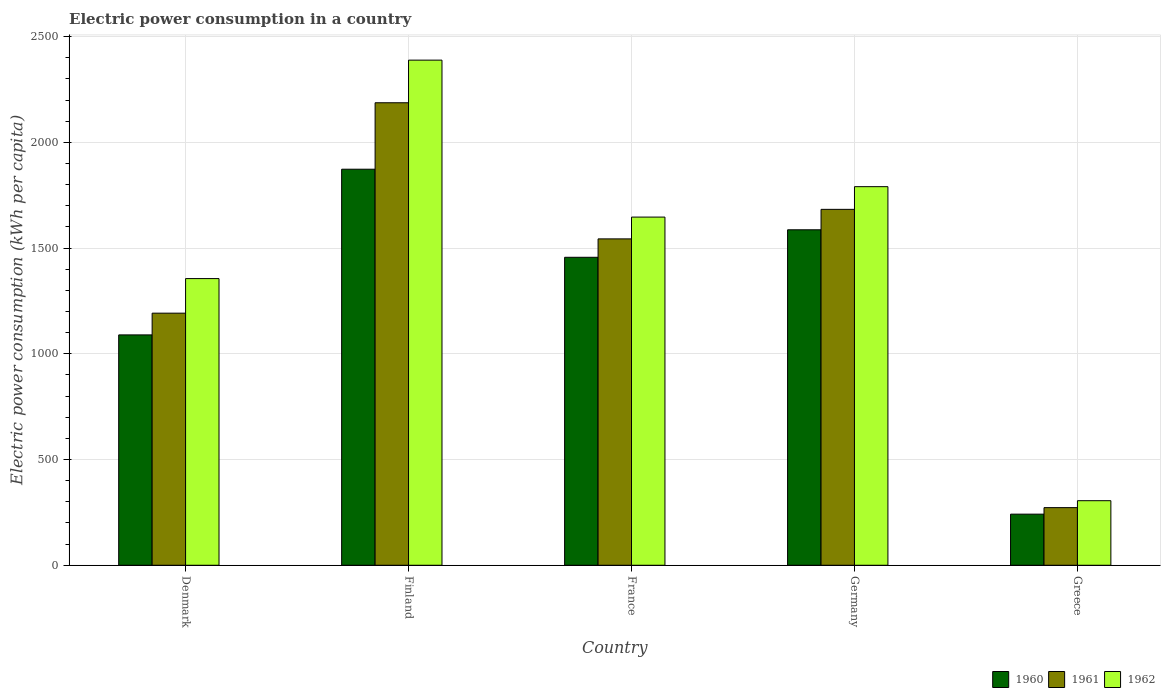How many different coloured bars are there?
Keep it short and to the point. 3. Are the number of bars on each tick of the X-axis equal?
Offer a very short reply. Yes. How many bars are there on the 2nd tick from the right?
Offer a very short reply. 3. What is the label of the 2nd group of bars from the left?
Make the answer very short. Finland. In how many cases, is the number of bars for a given country not equal to the number of legend labels?
Offer a very short reply. 0. What is the electric power consumption in in 1961 in France?
Your response must be concise. 1543.71. Across all countries, what is the maximum electric power consumption in in 1960?
Give a very brief answer. 1873.29. Across all countries, what is the minimum electric power consumption in in 1962?
Offer a terse response. 305.39. In which country was the electric power consumption in in 1961 maximum?
Keep it short and to the point. Finland. What is the total electric power consumption in in 1960 in the graph?
Ensure brevity in your answer.  6248.08. What is the difference between the electric power consumption in in 1962 in France and that in Germany?
Keep it short and to the point. -143.85. What is the difference between the electric power consumption in in 1960 in Greece and the electric power consumption in in 1962 in France?
Provide a short and direct response. -1405.11. What is the average electric power consumption in in 1961 per country?
Your answer should be compact. 1375.94. What is the difference between the electric power consumption in of/in 1962 and electric power consumption in of/in 1961 in Finland?
Your response must be concise. 201.59. What is the ratio of the electric power consumption in in 1961 in Denmark to that in France?
Your answer should be very brief. 0.77. Is the difference between the electric power consumption in in 1962 in Germany and Greece greater than the difference between the electric power consumption in in 1961 in Germany and Greece?
Keep it short and to the point. Yes. What is the difference between the highest and the second highest electric power consumption in in 1960?
Provide a short and direct response. -416.6. What is the difference between the highest and the lowest electric power consumption in in 1961?
Offer a terse response. 1915.06. What is the difference between two consecutive major ticks on the Y-axis?
Your answer should be compact. 500. Are the values on the major ticks of Y-axis written in scientific E-notation?
Your response must be concise. No. Does the graph contain any zero values?
Provide a short and direct response. No. Where does the legend appear in the graph?
Your response must be concise. Bottom right. How many legend labels are there?
Give a very brief answer. 3. What is the title of the graph?
Provide a succinct answer. Electric power consumption in a country. What is the label or title of the Y-axis?
Provide a short and direct response. Electric power consumption (kWh per capita). What is the Electric power consumption (kWh per capita) in 1960 in Denmark?
Offer a very short reply. 1089.61. What is the Electric power consumption (kWh per capita) in 1961 in Denmark?
Your response must be concise. 1192.41. What is the Electric power consumption (kWh per capita) in 1962 in Denmark?
Offer a terse response. 1355.93. What is the Electric power consumption (kWh per capita) in 1960 in Finland?
Offer a terse response. 1873.29. What is the Electric power consumption (kWh per capita) in 1961 in Finland?
Your answer should be compact. 2187.62. What is the Electric power consumption (kWh per capita) in 1962 in Finland?
Your answer should be very brief. 2389.21. What is the Electric power consumption (kWh per capita) of 1960 in France?
Offer a terse response. 1456.69. What is the Electric power consumption (kWh per capita) in 1961 in France?
Make the answer very short. 1543.71. What is the Electric power consumption (kWh per capita) of 1962 in France?
Provide a short and direct response. 1646.83. What is the Electric power consumption (kWh per capita) of 1960 in Germany?
Make the answer very short. 1586.75. What is the Electric power consumption (kWh per capita) of 1961 in Germany?
Make the answer very short. 1683.41. What is the Electric power consumption (kWh per capita) of 1962 in Germany?
Your answer should be compact. 1790.69. What is the Electric power consumption (kWh per capita) in 1960 in Greece?
Make the answer very short. 241.73. What is the Electric power consumption (kWh per capita) in 1961 in Greece?
Make the answer very short. 272.56. What is the Electric power consumption (kWh per capita) of 1962 in Greece?
Your response must be concise. 305.39. Across all countries, what is the maximum Electric power consumption (kWh per capita) in 1960?
Ensure brevity in your answer.  1873.29. Across all countries, what is the maximum Electric power consumption (kWh per capita) of 1961?
Keep it short and to the point. 2187.62. Across all countries, what is the maximum Electric power consumption (kWh per capita) in 1962?
Keep it short and to the point. 2389.21. Across all countries, what is the minimum Electric power consumption (kWh per capita) in 1960?
Offer a very short reply. 241.73. Across all countries, what is the minimum Electric power consumption (kWh per capita) in 1961?
Give a very brief answer. 272.56. Across all countries, what is the minimum Electric power consumption (kWh per capita) of 1962?
Make the answer very short. 305.39. What is the total Electric power consumption (kWh per capita) of 1960 in the graph?
Your response must be concise. 6248.08. What is the total Electric power consumption (kWh per capita) of 1961 in the graph?
Your answer should be very brief. 6879.72. What is the total Electric power consumption (kWh per capita) of 1962 in the graph?
Make the answer very short. 7488.05. What is the difference between the Electric power consumption (kWh per capita) in 1960 in Denmark and that in Finland?
Give a very brief answer. -783.68. What is the difference between the Electric power consumption (kWh per capita) in 1961 in Denmark and that in Finland?
Your answer should be very brief. -995.22. What is the difference between the Electric power consumption (kWh per capita) in 1962 in Denmark and that in Finland?
Offer a terse response. -1033.28. What is the difference between the Electric power consumption (kWh per capita) of 1960 in Denmark and that in France?
Provide a succinct answer. -367.08. What is the difference between the Electric power consumption (kWh per capita) in 1961 in Denmark and that in France?
Provide a succinct answer. -351.31. What is the difference between the Electric power consumption (kWh per capita) in 1962 in Denmark and that in France?
Provide a succinct answer. -290.9. What is the difference between the Electric power consumption (kWh per capita) in 1960 in Denmark and that in Germany?
Offer a terse response. -497.14. What is the difference between the Electric power consumption (kWh per capita) in 1961 in Denmark and that in Germany?
Keep it short and to the point. -491.01. What is the difference between the Electric power consumption (kWh per capita) in 1962 in Denmark and that in Germany?
Your answer should be compact. -434.76. What is the difference between the Electric power consumption (kWh per capita) of 1960 in Denmark and that in Greece?
Provide a succinct answer. 847.89. What is the difference between the Electric power consumption (kWh per capita) in 1961 in Denmark and that in Greece?
Your answer should be very brief. 919.84. What is the difference between the Electric power consumption (kWh per capita) of 1962 in Denmark and that in Greece?
Give a very brief answer. 1050.54. What is the difference between the Electric power consumption (kWh per capita) of 1960 in Finland and that in France?
Provide a succinct answer. 416.6. What is the difference between the Electric power consumption (kWh per capita) in 1961 in Finland and that in France?
Make the answer very short. 643.91. What is the difference between the Electric power consumption (kWh per capita) in 1962 in Finland and that in France?
Provide a succinct answer. 742.38. What is the difference between the Electric power consumption (kWh per capita) of 1960 in Finland and that in Germany?
Your response must be concise. 286.54. What is the difference between the Electric power consumption (kWh per capita) in 1961 in Finland and that in Germany?
Your answer should be very brief. 504.21. What is the difference between the Electric power consumption (kWh per capita) of 1962 in Finland and that in Germany?
Your answer should be compact. 598.52. What is the difference between the Electric power consumption (kWh per capita) in 1960 in Finland and that in Greece?
Your response must be concise. 1631.57. What is the difference between the Electric power consumption (kWh per capita) of 1961 in Finland and that in Greece?
Provide a short and direct response. 1915.06. What is the difference between the Electric power consumption (kWh per capita) in 1962 in Finland and that in Greece?
Your answer should be compact. 2083.82. What is the difference between the Electric power consumption (kWh per capita) of 1960 in France and that in Germany?
Make the answer very short. -130.06. What is the difference between the Electric power consumption (kWh per capita) of 1961 in France and that in Germany?
Offer a terse response. -139.7. What is the difference between the Electric power consumption (kWh per capita) in 1962 in France and that in Germany?
Your answer should be compact. -143.85. What is the difference between the Electric power consumption (kWh per capita) in 1960 in France and that in Greece?
Keep it short and to the point. 1214.97. What is the difference between the Electric power consumption (kWh per capita) of 1961 in France and that in Greece?
Provide a short and direct response. 1271.15. What is the difference between the Electric power consumption (kWh per capita) in 1962 in France and that in Greece?
Keep it short and to the point. 1341.44. What is the difference between the Electric power consumption (kWh per capita) of 1960 in Germany and that in Greece?
Your answer should be compact. 1345.02. What is the difference between the Electric power consumption (kWh per capita) in 1961 in Germany and that in Greece?
Give a very brief answer. 1410.85. What is the difference between the Electric power consumption (kWh per capita) in 1962 in Germany and that in Greece?
Your response must be concise. 1485.3. What is the difference between the Electric power consumption (kWh per capita) in 1960 in Denmark and the Electric power consumption (kWh per capita) in 1961 in Finland?
Give a very brief answer. -1098.01. What is the difference between the Electric power consumption (kWh per capita) of 1960 in Denmark and the Electric power consumption (kWh per capita) of 1962 in Finland?
Offer a terse response. -1299.6. What is the difference between the Electric power consumption (kWh per capita) of 1961 in Denmark and the Electric power consumption (kWh per capita) of 1962 in Finland?
Keep it short and to the point. -1196.8. What is the difference between the Electric power consumption (kWh per capita) of 1960 in Denmark and the Electric power consumption (kWh per capita) of 1961 in France?
Provide a short and direct response. -454.1. What is the difference between the Electric power consumption (kWh per capita) in 1960 in Denmark and the Electric power consumption (kWh per capita) in 1962 in France?
Keep it short and to the point. -557.22. What is the difference between the Electric power consumption (kWh per capita) in 1961 in Denmark and the Electric power consumption (kWh per capita) in 1962 in France?
Keep it short and to the point. -454.43. What is the difference between the Electric power consumption (kWh per capita) of 1960 in Denmark and the Electric power consumption (kWh per capita) of 1961 in Germany?
Give a very brief answer. -593.8. What is the difference between the Electric power consumption (kWh per capita) in 1960 in Denmark and the Electric power consumption (kWh per capita) in 1962 in Germany?
Offer a very short reply. -701.07. What is the difference between the Electric power consumption (kWh per capita) in 1961 in Denmark and the Electric power consumption (kWh per capita) in 1962 in Germany?
Your answer should be very brief. -598.28. What is the difference between the Electric power consumption (kWh per capita) of 1960 in Denmark and the Electric power consumption (kWh per capita) of 1961 in Greece?
Keep it short and to the point. 817.05. What is the difference between the Electric power consumption (kWh per capita) in 1960 in Denmark and the Electric power consumption (kWh per capita) in 1962 in Greece?
Offer a very short reply. 784.22. What is the difference between the Electric power consumption (kWh per capita) of 1961 in Denmark and the Electric power consumption (kWh per capita) of 1962 in Greece?
Give a very brief answer. 887.02. What is the difference between the Electric power consumption (kWh per capita) of 1960 in Finland and the Electric power consumption (kWh per capita) of 1961 in France?
Provide a short and direct response. 329.58. What is the difference between the Electric power consumption (kWh per capita) of 1960 in Finland and the Electric power consumption (kWh per capita) of 1962 in France?
Provide a short and direct response. 226.46. What is the difference between the Electric power consumption (kWh per capita) in 1961 in Finland and the Electric power consumption (kWh per capita) in 1962 in France?
Provide a short and direct response. 540.79. What is the difference between the Electric power consumption (kWh per capita) of 1960 in Finland and the Electric power consumption (kWh per capita) of 1961 in Germany?
Offer a terse response. 189.88. What is the difference between the Electric power consumption (kWh per capita) in 1960 in Finland and the Electric power consumption (kWh per capita) in 1962 in Germany?
Keep it short and to the point. 82.61. What is the difference between the Electric power consumption (kWh per capita) of 1961 in Finland and the Electric power consumption (kWh per capita) of 1962 in Germany?
Provide a short and direct response. 396.94. What is the difference between the Electric power consumption (kWh per capita) in 1960 in Finland and the Electric power consumption (kWh per capita) in 1961 in Greece?
Make the answer very short. 1600.73. What is the difference between the Electric power consumption (kWh per capita) in 1960 in Finland and the Electric power consumption (kWh per capita) in 1962 in Greece?
Ensure brevity in your answer.  1567.9. What is the difference between the Electric power consumption (kWh per capita) in 1961 in Finland and the Electric power consumption (kWh per capita) in 1962 in Greece?
Keep it short and to the point. 1882.23. What is the difference between the Electric power consumption (kWh per capita) in 1960 in France and the Electric power consumption (kWh per capita) in 1961 in Germany?
Offer a very short reply. -226.72. What is the difference between the Electric power consumption (kWh per capita) in 1960 in France and the Electric power consumption (kWh per capita) in 1962 in Germany?
Offer a very short reply. -333.99. What is the difference between the Electric power consumption (kWh per capita) of 1961 in France and the Electric power consumption (kWh per capita) of 1962 in Germany?
Make the answer very short. -246.98. What is the difference between the Electric power consumption (kWh per capita) of 1960 in France and the Electric power consumption (kWh per capita) of 1961 in Greece?
Offer a very short reply. 1184.13. What is the difference between the Electric power consumption (kWh per capita) of 1960 in France and the Electric power consumption (kWh per capita) of 1962 in Greece?
Ensure brevity in your answer.  1151.3. What is the difference between the Electric power consumption (kWh per capita) of 1961 in France and the Electric power consumption (kWh per capita) of 1962 in Greece?
Keep it short and to the point. 1238.32. What is the difference between the Electric power consumption (kWh per capita) in 1960 in Germany and the Electric power consumption (kWh per capita) in 1961 in Greece?
Your answer should be very brief. 1314.19. What is the difference between the Electric power consumption (kWh per capita) of 1960 in Germany and the Electric power consumption (kWh per capita) of 1962 in Greece?
Offer a very short reply. 1281.36. What is the difference between the Electric power consumption (kWh per capita) in 1961 in Germany and the Electric power consumption (kWh per capita) in 1962 in Greece?
Provide a succinct answer. 1378.03. What is the average Electric power consumption (kWh per capita) of 1960 per country?
Provide a succinct answer. 1249.62. What is the average Electric power consumption (kWh per capita) in 1961 per country?
Offer a very short reply. 1375.94. What is the average Electric power consumption (kWh per capita) in 1962 per country?
Offer a terse response. 1497.61. What is the difference between the Electric power consumption (kWh per capita) of 1960 and Electric power consumption (kWh per capita) of 1961 in Denmark?
Provide a short and direct response. -102.79. What is the difference between the Electric power consumption (kWh per capita) in 1960 and Electric power consumption (kWh per capita) in 1962 in Denmark?
Your answer should be very brief. -266.32. What is the difference between the Electric power consumption (kWh per capita) of 1961 and Electric power consumption (kWh per capita) of 1962 in Denmark?
Ensure brevity in your answer.  -163.53. What is the difference between the Electric power consumption (kWh per capita) of 1960 and Electric power consumption (kWh per capita) of 1961 in Finland?
Make the answer very short. -314.33. What is the difference between the Electric power consumption (kWh per capita) in 1960 and Electric power consumption (kWh per capita) in 1962 in Finland?
Offer a terse response. -515.92. What is the difference between the Electric power consumption (kWh per capita) in 1961 and Electric power consumption (kWh per capita) in 1962 in Finland?
Give a very brief answer. -201.59. What is the difference between the Electric power consumption (kWh per capita) in 1960 and Electric power consumption (kWh per capita) in 1961 in France?
Your answer should be very brief. -87.02. What is the difference between the Electric power consumption (kWh per capita) of 1960 and Electric power consumption (kWh per capita) of 1962 in France?
Offer a very short reply. -190.14. What is the difference between the Electric power consumption (kWh per capita) in 1961 and Electric power consumption (kWh per capita) in 1962 in France?
Your response must be concise. -103.12. What is the difference between the Electric power consumption (kWh per capita) in 1960 and Electric power consumption (kWh per capita) in 1961 in Germany?
Offer a terse response. -96.67. What is the difference between the Electric power consumption (kWh per capita) in 1960 and Electric power consumption (kWh per capita) in 1962 in Germany?
Your response must be concise. -203.94. What is the difference between the Electric power consumption (kWh per capita) of 1961 and Electric power consumption (kWh per capita) of 1962 in Germany?
Provide a short and direct response. -107.27. What is the difference between the Electric power consumption (kWh per capita) of 1960 and Electric power consumption (kWh per capita) of 1961 in Greece?
Your response must be concise. -30.84. What is the difference between the Electric power consumption (kWh per capita) of 1960 and Electric power consumption (kWh per capita) of 1962 in Greece?
Offer a very short reply. -63.66. What is the difference between the Electric power consumption (kWh per capita) of 1961 and Electric power consumption (kWh per capita) of 1962 in Greece?
Your answer should be compact. -32.83. What is the ratio of the Electric power consumption (kWh per capita) in 1960 in Denmark to that in Finland?
Ensure brevity in your answer.  0.58. What is the ratio of the Electric power consumption (kWh per capita) in 1961 in Denmark to that in Finland?
Your answer should be compact. 0.55. What is the ratio of the Electric power consumption (kWh per capita) of 1962 in Denmark to that in Finland?
Keep it short and to the point. 0.57. What is the ratio of the Electric power consumption (kWh per capita) of 1960 in Denmark to that in France?
Give a very brief answer. 0.75. What is the ratio of the Electric power consumption (kWh per capita) in 1961 in Denmark to that in France?
Offer a terse response. 0.77. What is the ratio of the Electric power consumption (kWh per capita) in 1962 in Denmark to that in France?
Ensure brevity in your answer.  0.82. What is the ratio of the Electric power consumption (kWh per capita) of 1960 in Denmark to that in Germany?
Keep it short and to the point. 0.69. What is the ratio of the Electric power consumption (kWh per capita) in 1961 in Denmark to that in Germany?
Make the answer very short. 0.71. What is the ratio of the Electric power consumption (kWh per capita) of 1962 in Denmark to that in Germany?
Offer a very short reply. 0.76. What is the ratio of the Electric power consumption (kWh per capita) in 1960 in Denmark to that in Greece?
Your answer should be compact. 4.51. What is the ratio of the Electric power consumption (kWh per capita) of 1961 in Denmark to that in Greece?
Make the answer very short. 4.37. What is the ratio of the Electric power consumption (kWh per capita) of 1962 in Denmark to that in Greece?
Keep it short and to the point. 4.44. What is the ratio of the Electric power consumption (kWh per capita) in 1960 in Finland to that in France?
Your answer should be very brief. 1.29. What is the ratio of the Electric power consumption (kWh per capita) in 1961 in Finland to that in France?
Offer a very short reply. 1.42. What is the ratio of the Electric power consumption (kWh per capita) in 1962 in Finland to that in France?
Keep it short and to the point. 1.45. What is the ratio of the Electric power consumption (kWh per capita) in 1960 in Finland to that in Germany?
Your answer should be very brief. 1.18. What is the ratio of the Electric power consumption (kWh per capita) in 1961 in Finland to that in Germany?
Your response must be concise. 1.3. What is the ratio of the Electric power consumption (kWh per capita) in 1962 in Finland to that in Germany?
Provide a short and direct response. 1.33. What is the ratio of the Electric power consumption (kWh per capita) of 1960 in Finland to that in Greece?
Give a very brief answer. 7.75. What is the ratio of the Electric power consumption (kWh per capita) of 1961 in Finland to that in Greece?
Make the answer very short. 8.03. What is the ratio of the Electric power consumption (kWh per capita) of 1962 in Finland to that in Greece?
Make the answer very short. 7.82. What is the ratio of the Electric power consumption (kWh per capita) in 1960 in France to that in Germany?
Keep it short and to the point. 0.92. What is the ratio of the Electric power consumption (kWh per capita) of 1961 in France to that in Germany?
Ensure brevity in your answer.  0.92. What is the ratio of the Electric power consumption (kWh per capita) in 1962 in France to that in Germany?
Your answer should be compact. 0.92. What is the ratio of the Electric power consumption (kWh per capita) of 1960 in France to that in Greece?
Offer a terse response. 6.03. What is the ratio of the Electric power consumption (kWh per capita) in 1961 in France to that in Greece?
Provide a short and direct response. 5.66. What is the ratio of the Electric power consumption (kWh per capita) of 1962 in France to that in Greece?
Keep it short and to the point. 5.39. What is the ratio of the Electric power consumption (kWh per capita) of 1960 in Germany to that in Greece?
Make the answer very short. 6.56. What is the ratio of the Electric power consumption (kWh per capita) of 1961 in Germany to that in Greece?
Your answer should be very brief. 6.18. What is the ratio of the Electric power consumption (kWh per capita) of 1962 in Germany to that in Greece?
Offer a terse response. 5.86. What is the difference between the highest and the second highest Electric power consumption (kWh per capita) of 1960?
Provide a short and direct response. 286.54. What is the difference between the highest and the second highest Electric power consumption (kWh per capita) in 1961?
Provide a succinct answer. 504.21. What is the difference between the highest and the second highest Electric power consumption (kWh per capita) of 1962?
Give a very brief answer. 598.52. What is the difference between the highest and the lowest Electric power consumption (kWh per capita) in 1960?
Make the answer very short. 1631.57. What is the difference between the highest and the lowest Electric power consumption (kWh per capita) in 1961?
Your response must be concise. 1915.06. What is the difference between the highest and the lowest Electric power consumption (kWh per capita) of 1962?
Your response must be concise. 2083.82. 